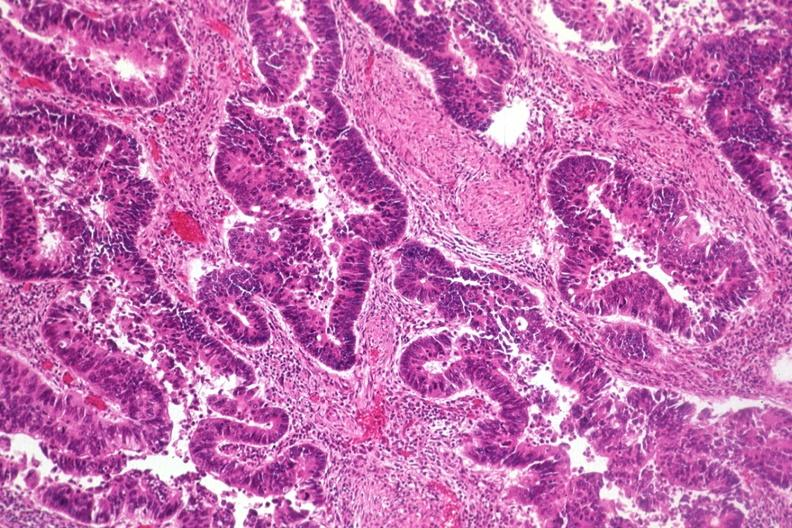where is this from?
Answer the question using a single word or phrase. Gastrointestinal system 